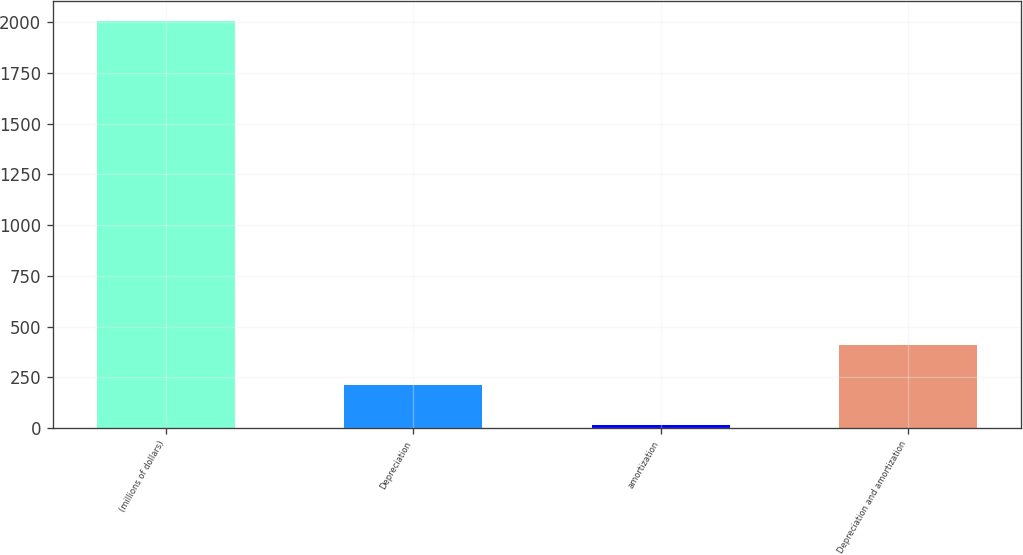Convert chart to OTSL. <chart><loc_0><loc_0><loc_500><loc_500><bar_chart><fcel>(millions of dollars)<fcel>Depreciation<fcel>amortization<fcel>Depreciation and amortization<nl><fcel>2005<fcel>211.93<fcel>12.7<fcel>411.16<nl></chart> 